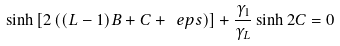Convert formula to latex. <formula><loc_0><loc_0><loc_500><loc_500>\sinh \left [ 2 \left ( ( L - 1 ) B + C + \ e p s \right ) \right ] + \frac { \gamma _ { 1 } } { \gamma _ { L } } \sinh 2 C = 0</formula> 